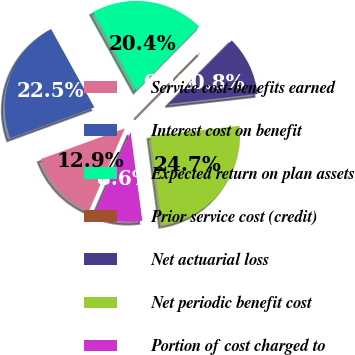Convert chart. <chart><loc_0><loc_0><loc_500><loc_500><pie_chart><fcel>Service cost-benefits earned<fcel>Interest cost on benefit<fcel>Expected return on plan assets<fcel>Prior service cost (credit)<fcel>Net actuarial loss<fcel>Net periodic benefit cost<fcel>Portion of cost charged to<nl><fcel>12.9%<fcel>22.55%<fcel>20.41%<fcel>0.08%<fcel>10.76%<fcel>24.7%<fcel>8.61%<nl></chart> 